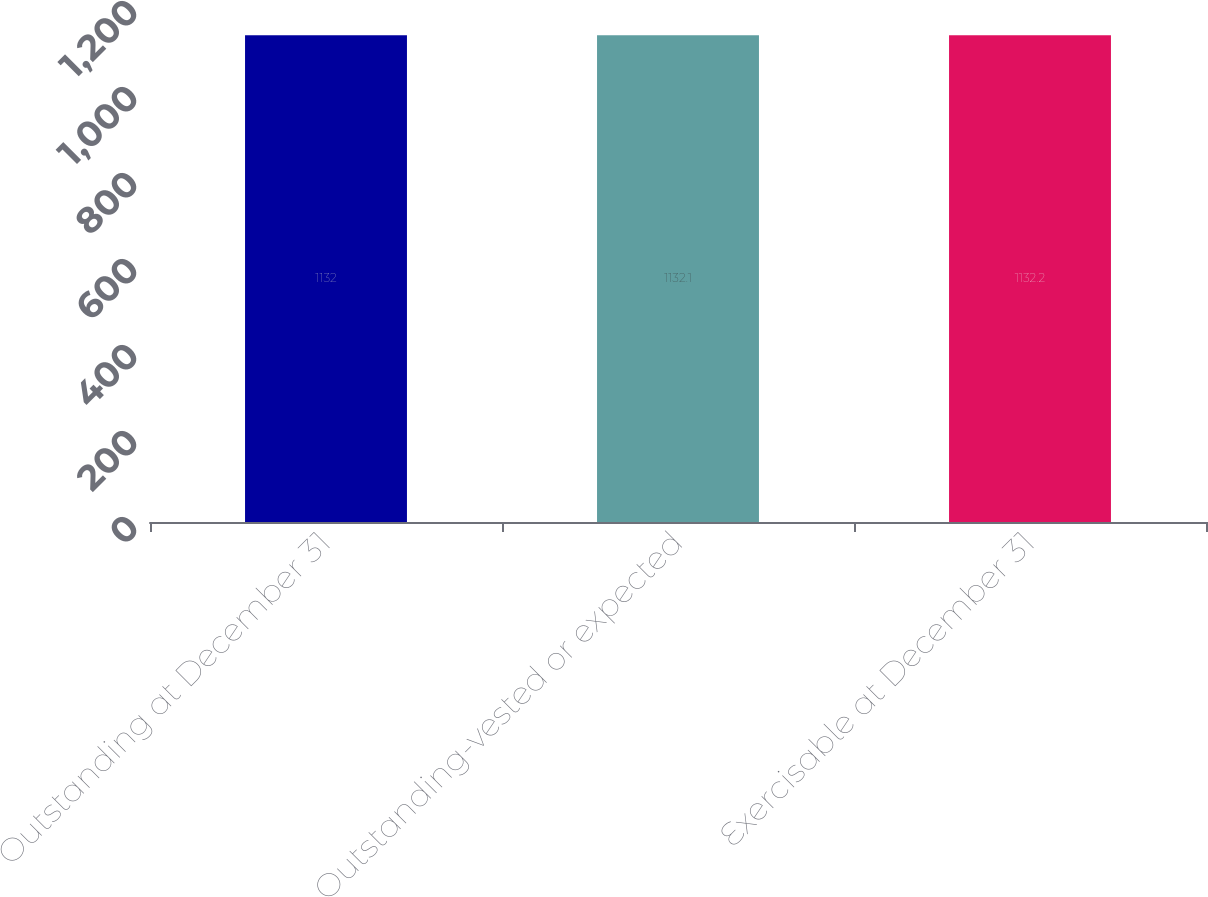Convert chart. <chart><loc_0><loc_0><loc_500><loc_500><bar_chart><fcel>Outstanding at December 31<fcel>Outstanding-vested or expected<fcel>Exercisable at December 31<nl><fcel>1132<fcel>1132.1<fcel>1132.2<nl></chart> 